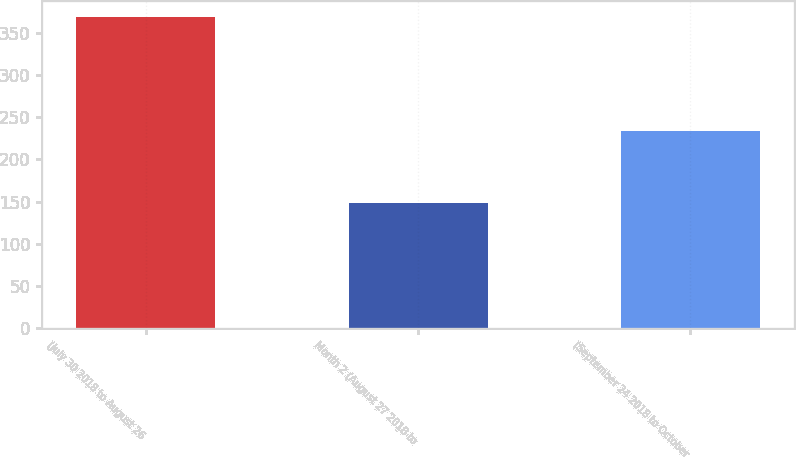<chart> <loc_0><loc_0><loc_500><loc_500><bar_chart><fcel>(July 30 2018 to August 26<fcel>Month 2 (August 27 2018 to<fcel>(September 24 2018 to October<nl><fcel>369<fcel>148<fcel>234<nl></chart> 